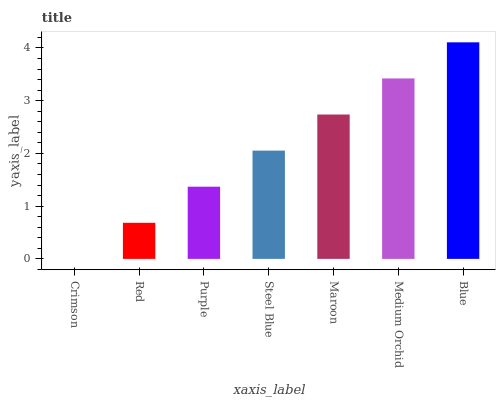Is Crimson the minimum?
Answer yes or no. Yes. Is Blue the maximum?
Answer yes or no. Yes. Is Red the minimum?
Answer yes or no. No. Is Red the maximum?
Answer yes or no. No. Is Red greater than Crimson?
Answer yes or no. Yes. Is Crimson less than Red?
Answer yes or no. Yes. Is Crimson greater than Red?
Answer yes or no. No. Is Red less than Crimson?
Answer yes or no. No. Is Steel Blue the high median?
Answer yes or no. Yes. Is Steel Blue the low median?
Answer yes or no. Yes. Is Blue the high median?
Answer yes or no. No. Is Crimson the low median?
Answer yes or no. No. 